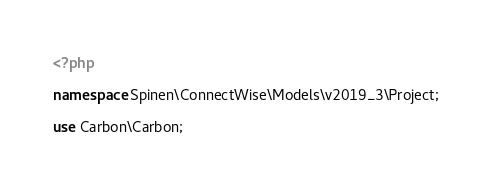<code> <loc_0><loc_0><loc_500><loc_500><_PHP_><?php

namespace Spinen\ConnectWise\Models\v2019_3\Project;

use Carbon\Carbon;</code> 